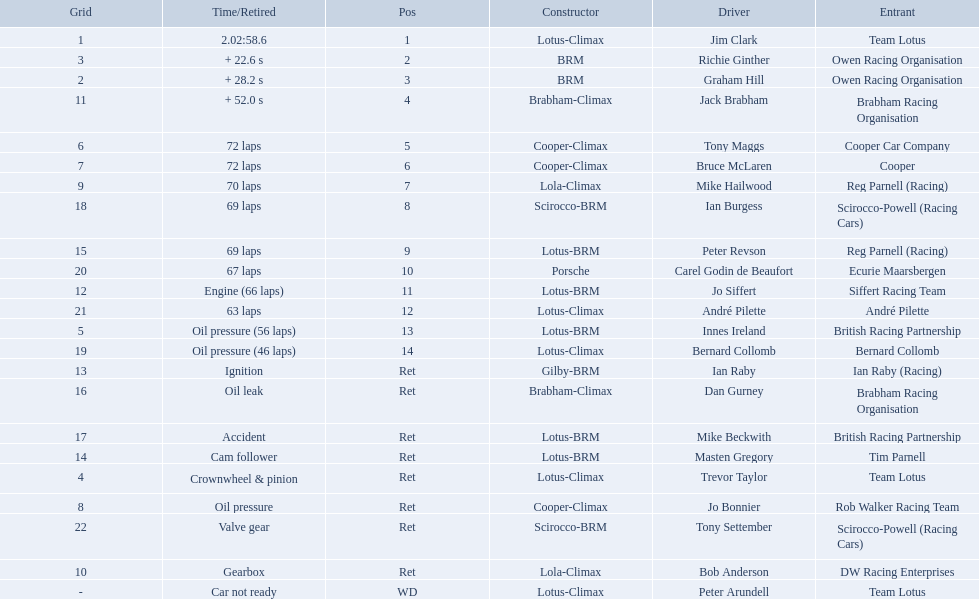Who were the two that that a similar problem? Innes Ireland. What was their common problem? Oil pressure. 